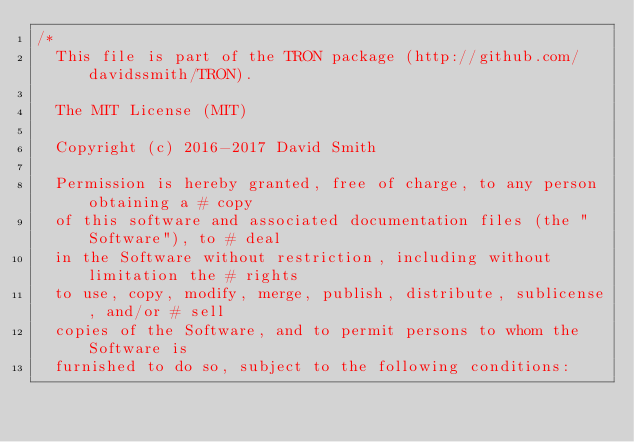<code> <loc_0><loc_0><loc_500><loc_500><_Cuda_>/*
  This file is part of the TRON package (http://github.com/davidssmith/TRON).

  The MIT License (MIT)

  Copyright (c) 2016-2017 David Smith

  Permission is hereby granted, free of charge, to any person obtaining a # copy
  of this software and associated documentation files (the "Software"), to # deal
  in the Software without restriction, including without limitation the # rights
  to use, copy, modify, merge, publish, distribute, sublicense, and/or # sell
  copies of the Software, and to permit persons to whom the Software is
  furnished to do so, subject to the following conditions:
</code> 